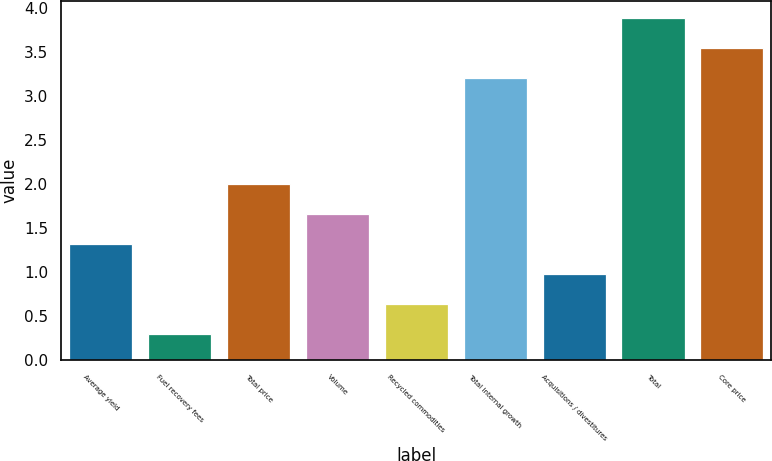<chart> <loc_0><loc_0><loc_500><loc_500><bar_chart><fcel>Average yield<fcel>Fuel recovery fees<fcel>Total price<fcel>Volume<fcel>Recycled commodities<fcel>Total internal growth<fcel>Acquisitions / divestitures<fcel>Total<fcel>Core price<nl><fcel>1.32<fcel>0.3<fcel>2<fcel>1.66<fcel>0.64<fcel>3.2<fcel>0.98<fcel>3.88<fcel>3.54<nl></chart> 